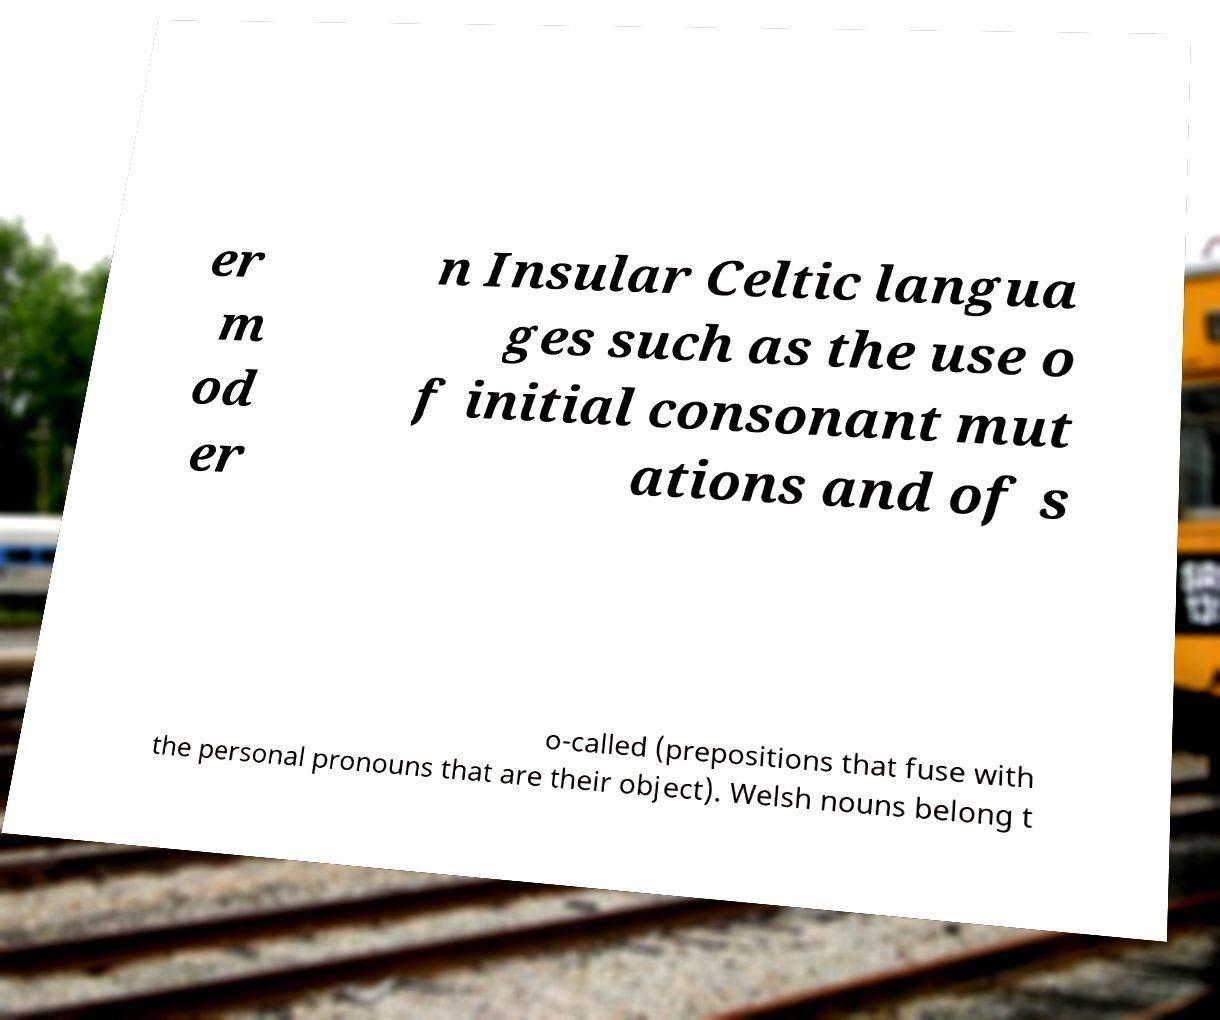What messages or text are displayed in this image? I need them in a readable, typed format. er m od er n Insular Celtic langua ges such as the use o f initial consonant mut ations and of s o-called (prepositions that fuse with the personal pronouns that are their object). Welsh nouns belong t 